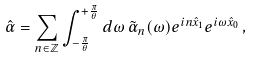Convert formula to latex. <formula><loc_0><loc_0><loc_500><loc_500>\hat { \alpha } = \sum _ { n \in \mathbb { Z } } \int _ { - \frac { \pi } { \theta } } ^ { + \frac { \pi } { \theta } } d \omega \, \tilde { \alpha } _ { n } ( \omega ) e ^ { i n \hat { x } _ { 1 } } e ^ { i \omega \hat { x } _ { 0 } } \, ,</formula> 